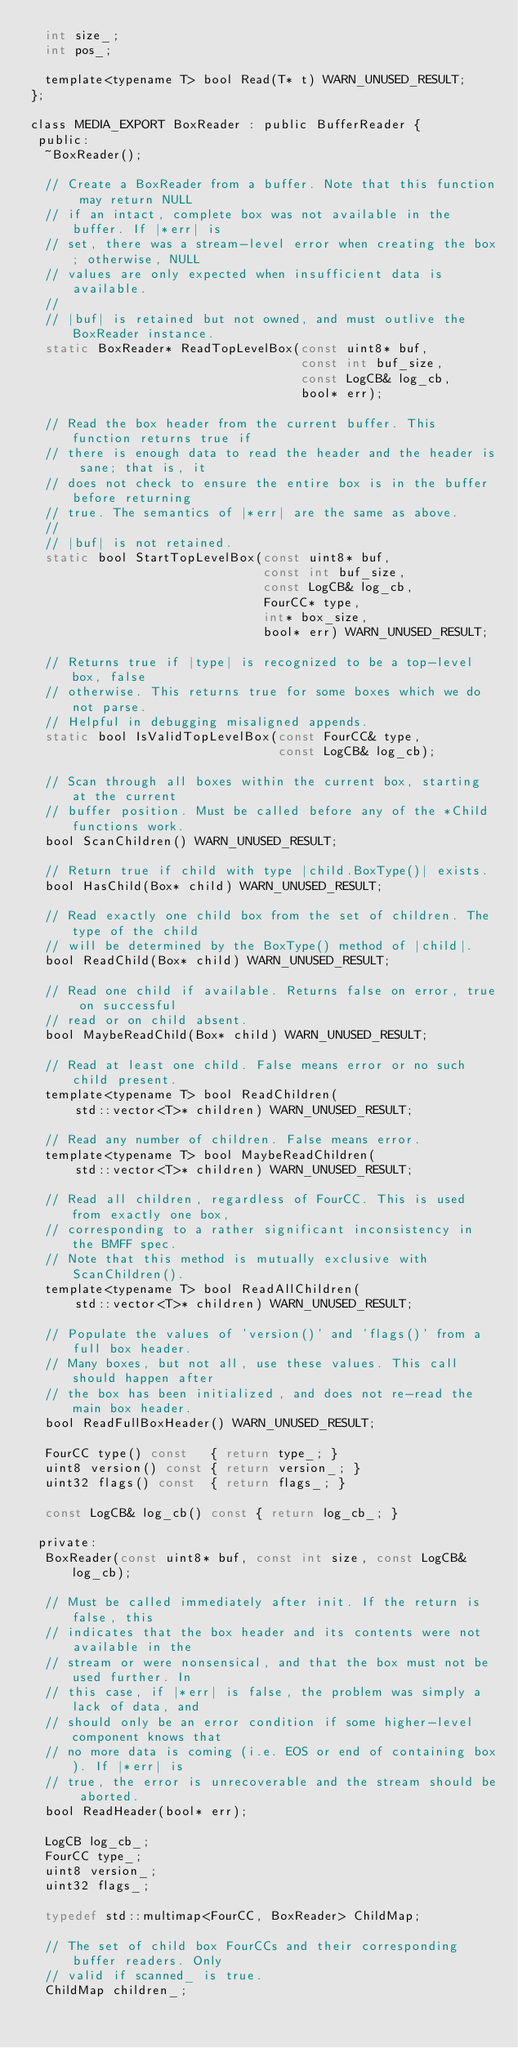Convert code to text. <code><loc_0><loc_0><loc_500><loc_500><_C_>  int size_;
  int pos_;

  template<typename T> bool Read(T* t) WARN_UNUSED_RESULT;
};

class MEDIA_EXPORT BoxReader : public BufferReader {
 public:
  ~BoxReader();

  // Create a BoxReader from a buffer. Note that this function may return NULL
  // if an intact, complete box was not available in the buffer. If |*err| is
  // set, there was a stream-level error when creating the box; otherwise, NULL
  // values are only expected when insufficient data is available.
  //
  // |buf| is retained but not owned, and must outlive the BoxReader instance.
  static BoxReader* ReadTopLevelBox(const uint8* buf,
                                    const int buf_size,
                                    const LogCB& log_cb,
                                    bool* err);

  // Read the box header from the current buffer. This function returns true if
  // there is enough data to read the header and the header is sane; that is, it
  // does not check to ensure the entire box is in the buffer before returning
  // true. The semantics of |*err| are the same as above.
  //
  // |buf| is not retained.
  static bool StartTopLevelBox(const uint8* buf,
                               const int buf_size,
                               const LogCB& log_cb,
                               FourCC* type,
                               int* box_size,
                               bool* err) WARN_UNUSED_RESULT;

  // Returns true if |type| is recognized to be a top-level box, false
  // otherwise. This returns true for some boxes which we do not parse.
  // Helpful in debugging misaligned appends.
  static bool IsValidTopLevelBox(const FourCC& type,
                                 const LogCB& log_cb);

  // Scan through all boxes within the current box, starting at the current
  // buffer position. Must be called before any of the *Child functions work.
  bool ScanChildren() WARN_UNUSED_RESULT;

  // Return true if child with type |child.BoxType()| exists.
  bool HasChild(Box* child) WARN_UNUSED_RESULT;

  // Read exactly one child box from the set of children. The type of the child
  // will be determined by the BoxType() method of |child|.
  bool ReadChild(Box* child) WARN_UNUSED_RESULT;

  // Read one child if available. Returns false on error, true on successful
  // read or on child absent.
  bool MaybeReadChild(Box* child) WARN_UNUSED_RESULT;

  // Read at least one child. False means error or no such child present.
  template<typename T> bool ReadChildren(
      std::vector<T>* children) WARN_UNUSED_RESULT;

  // Read any number of children. False means error.
  template<typename T> bool MaybeReadChildren(
      std::vector<T>* children) WARN_UNUSED_RESULT;

  // Read all children, regardless of FourCC. This is used from exactly one box,
  // corresponding to a rather significant inconsistency in the BMFF spec.
  // Note that this method is mutually exclusive with ScanChildren().
  template<typename T> bool ReadAllChildren(
      std::vector<T>* children) WARN_UNUSED_RESULT;

  // Populate the values of 'version()' and 'flags()' from a full box header.
  // Many boxes, but not all, use these values. This call should happen after
  // the box has been initialized, and does not re-read the main box header.
  bool ReadFullBoxHeader() WARN_UNUSED_RESULT;

  FourCC type() const   { return type_; }
  uint8 version() const { return version_; }
  uint32 flags() const  { return flags_; }

  const LogCB& log_cb() const { return log_cb_; }

 private:
  BoxReader(const uint8* buf, const int size, const LogCB& log_cb);

  // Must be called immediately after init. If the return is false, this
  // indicates that the box header and its contents were not available in the
  // stream or were nonsensical, and that the box must not be used further. In
  // this case, if |*err| is false, the problem was simply a lack of data, and
  // should only be an error condition if some higher-level component knows that
  // no more data is coming (i.e. EOS or end of containing box). If |*err| is
  // true, the error is unrecoverable and the stream should be aborted.
  bool ReadHeader(bool* err);

  LogCB log_cb_;
  FourCC type_;
  uint8 version_;
  uint32 flags_;

  typedef std::multimap<FourCC, BoxReader> ChildMap;

  // The set of child box FourCCs and their corresponding buffer readers. Only
  // valid if scanned_ is true.
  ChildMap children_;</code> 